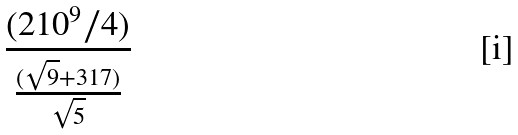Convert formula to latex. <formula><loc_0><loc_0><loc_500><loc_500>\frac { ( 2 1 0 ^ { 9 } / 4 ) } { \frac { ( \sqrt { 9 } + 3 1 7 ) } { \sqrt { 5 } } }</formula> 